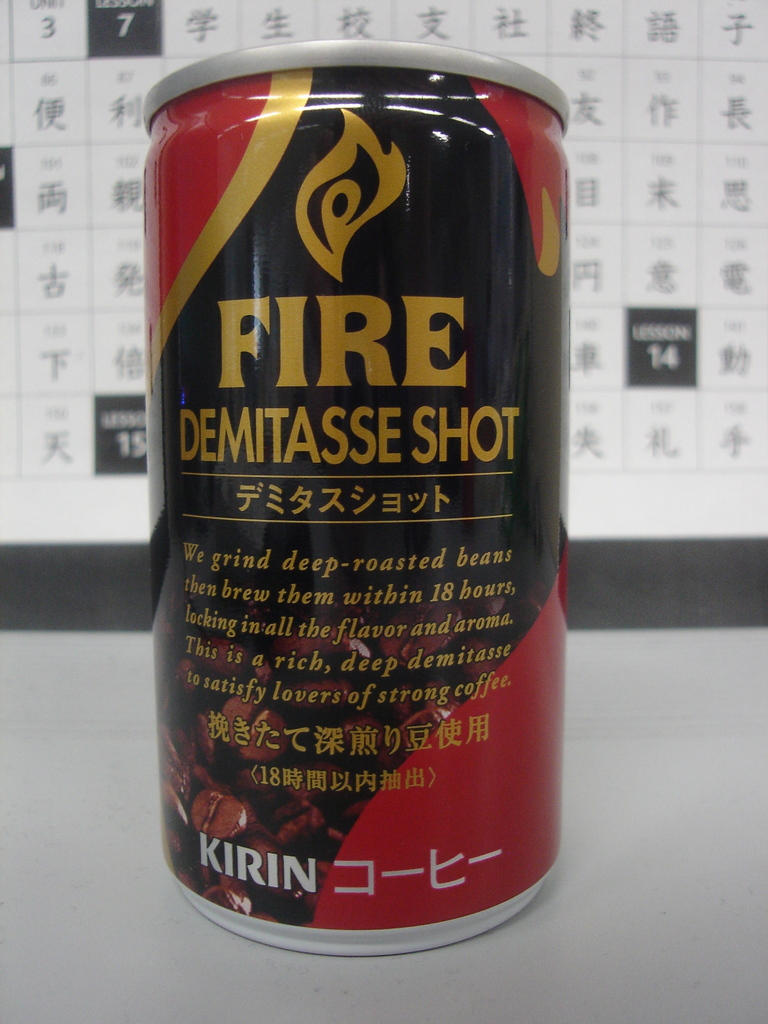Can you describe how the Kirin Fire Demitasse Shot differentiates itself from other canned coffee products? Kirin's Fire Demitasse Shot differentiates itself by using beans that are deep-roasted and brewing them within 18 hours after grinding. This process intends to maximize the preservation of flavor and aroma, producing a richer and deeper coffee shot, specifically crafted for lovers of strong coffee. 